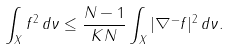<formula> <loc_0><loc_0><loc_500><loc_500>\int _ { X } f ^ { 2 } \, d \nu \leq \frac { N - 1 } { K N } \int _ { X } | \nabla ^ { - } f | ^ { 2 } \, d \nu .</formula> 